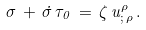Convert formula to latex. <formula><loc_0><loc_0><loc_500><loc_500>\sigma \, + \, \dot { \sigma } \, \tau _ { 0 } \, = \, \zeta \, u ^ { \rho } _ { ; \, \rho } \, .</formula> 